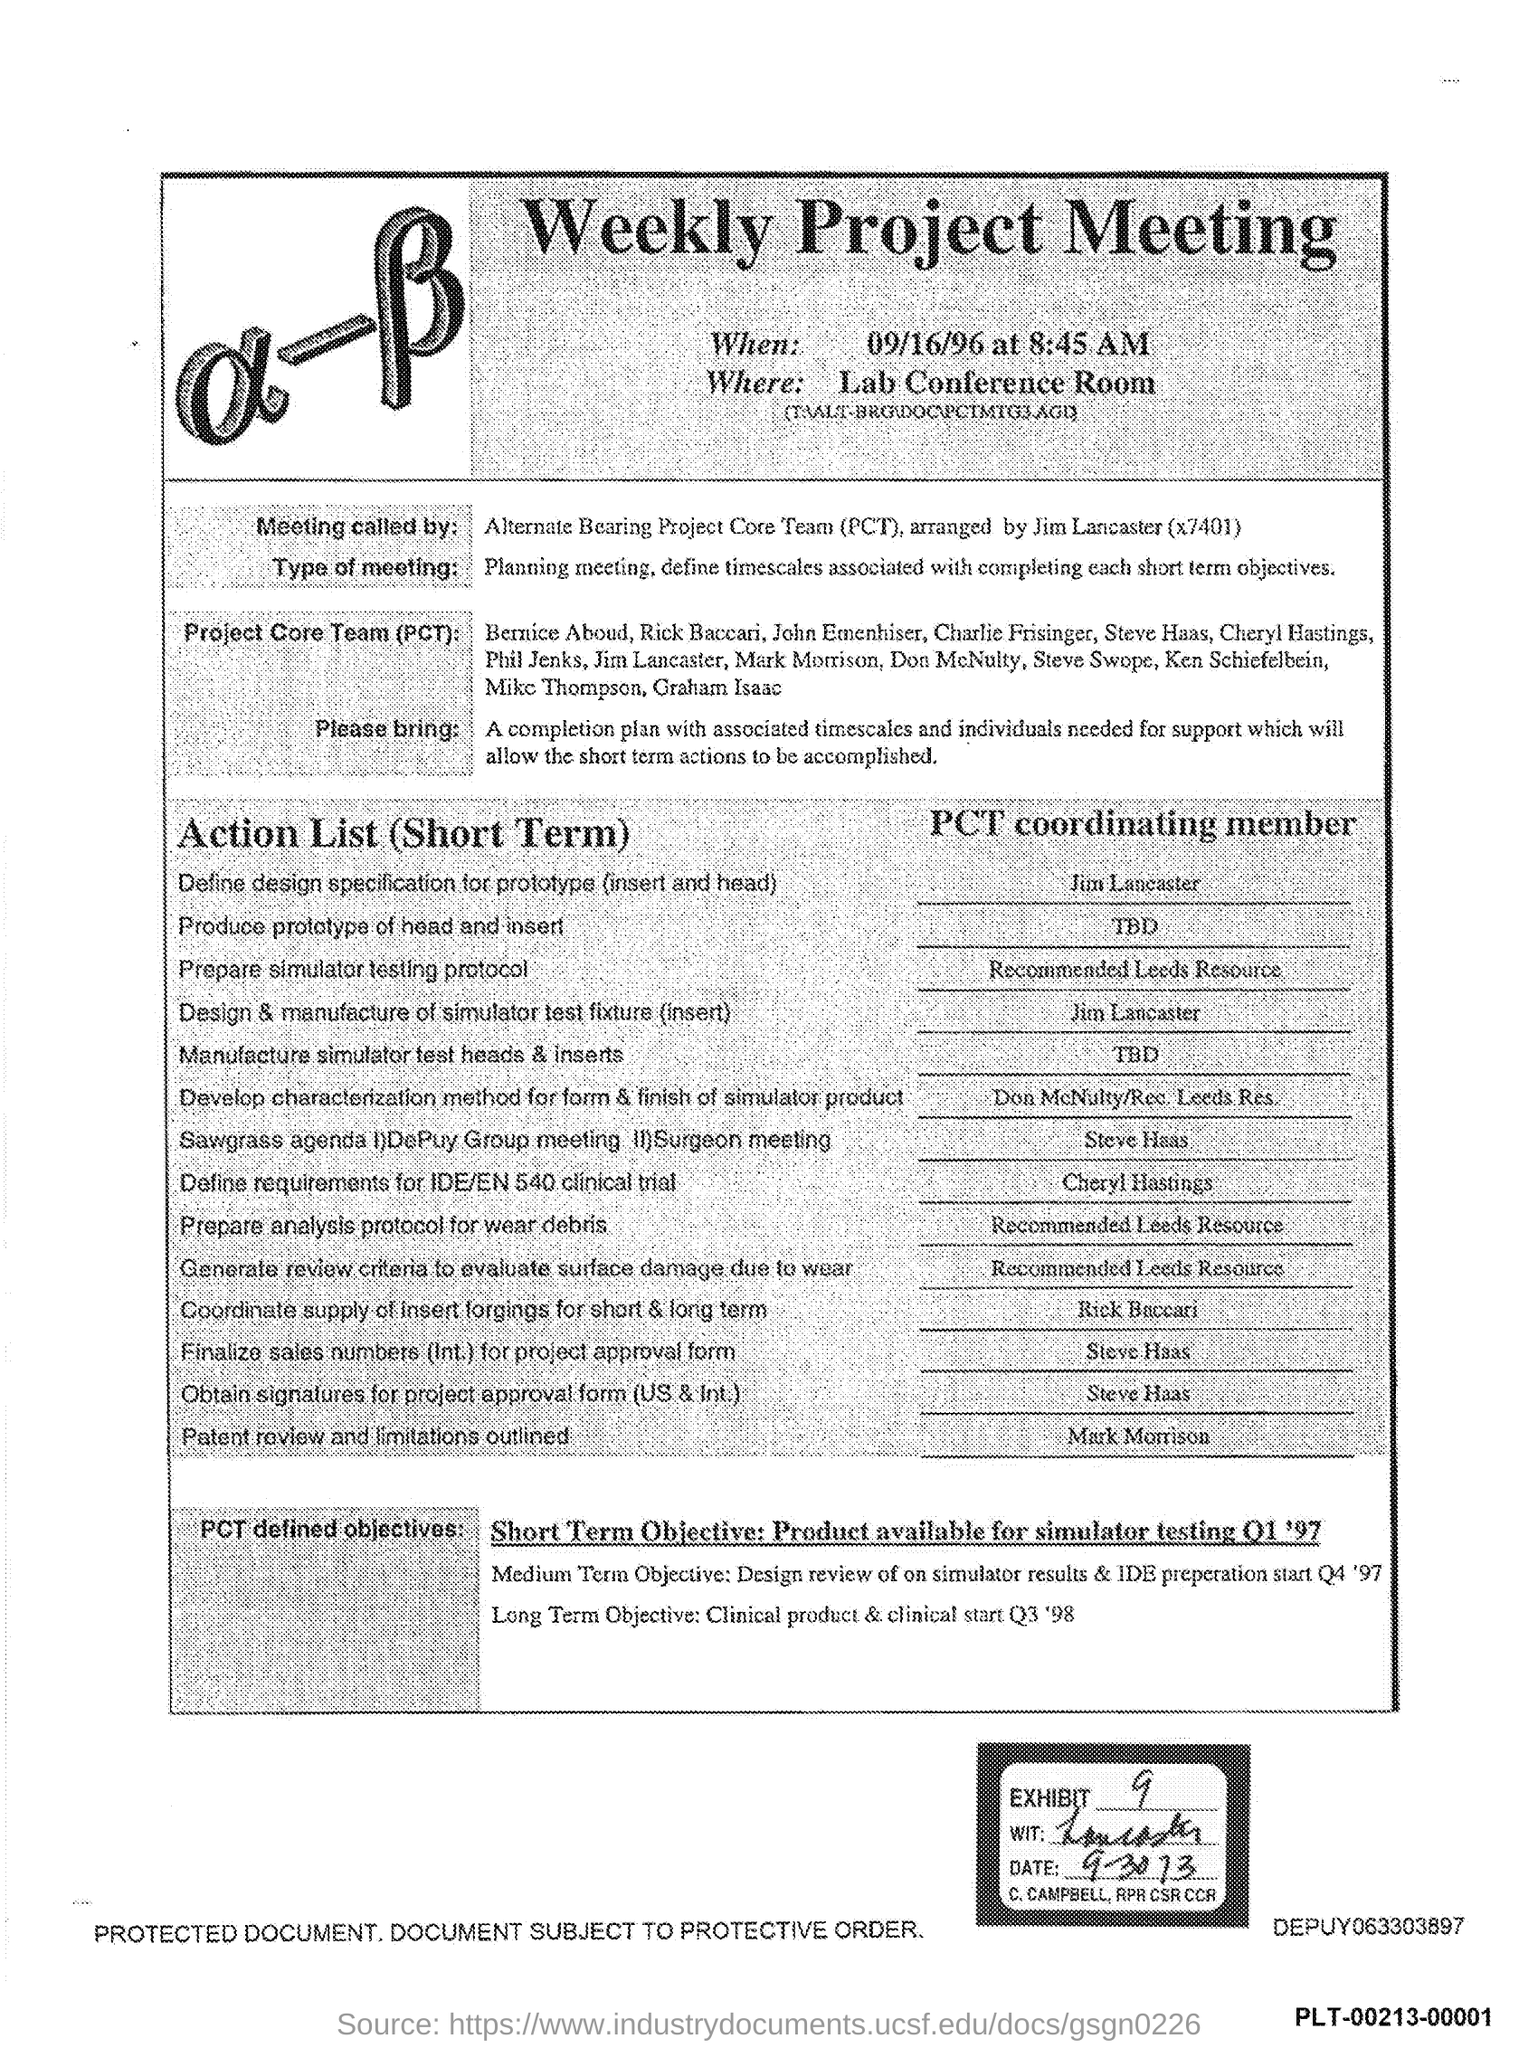Point out several critical features in this image. The Exhibit Number is 9. The weekly project meeting is scheduled to take place in the lab's conference room. The title of the document is 'Weekly Project Meeting'. 